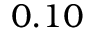Convert formula to latex. <formula><loc_0><loc_0><loc_500><loc_500>0 . 1 0</formula> 